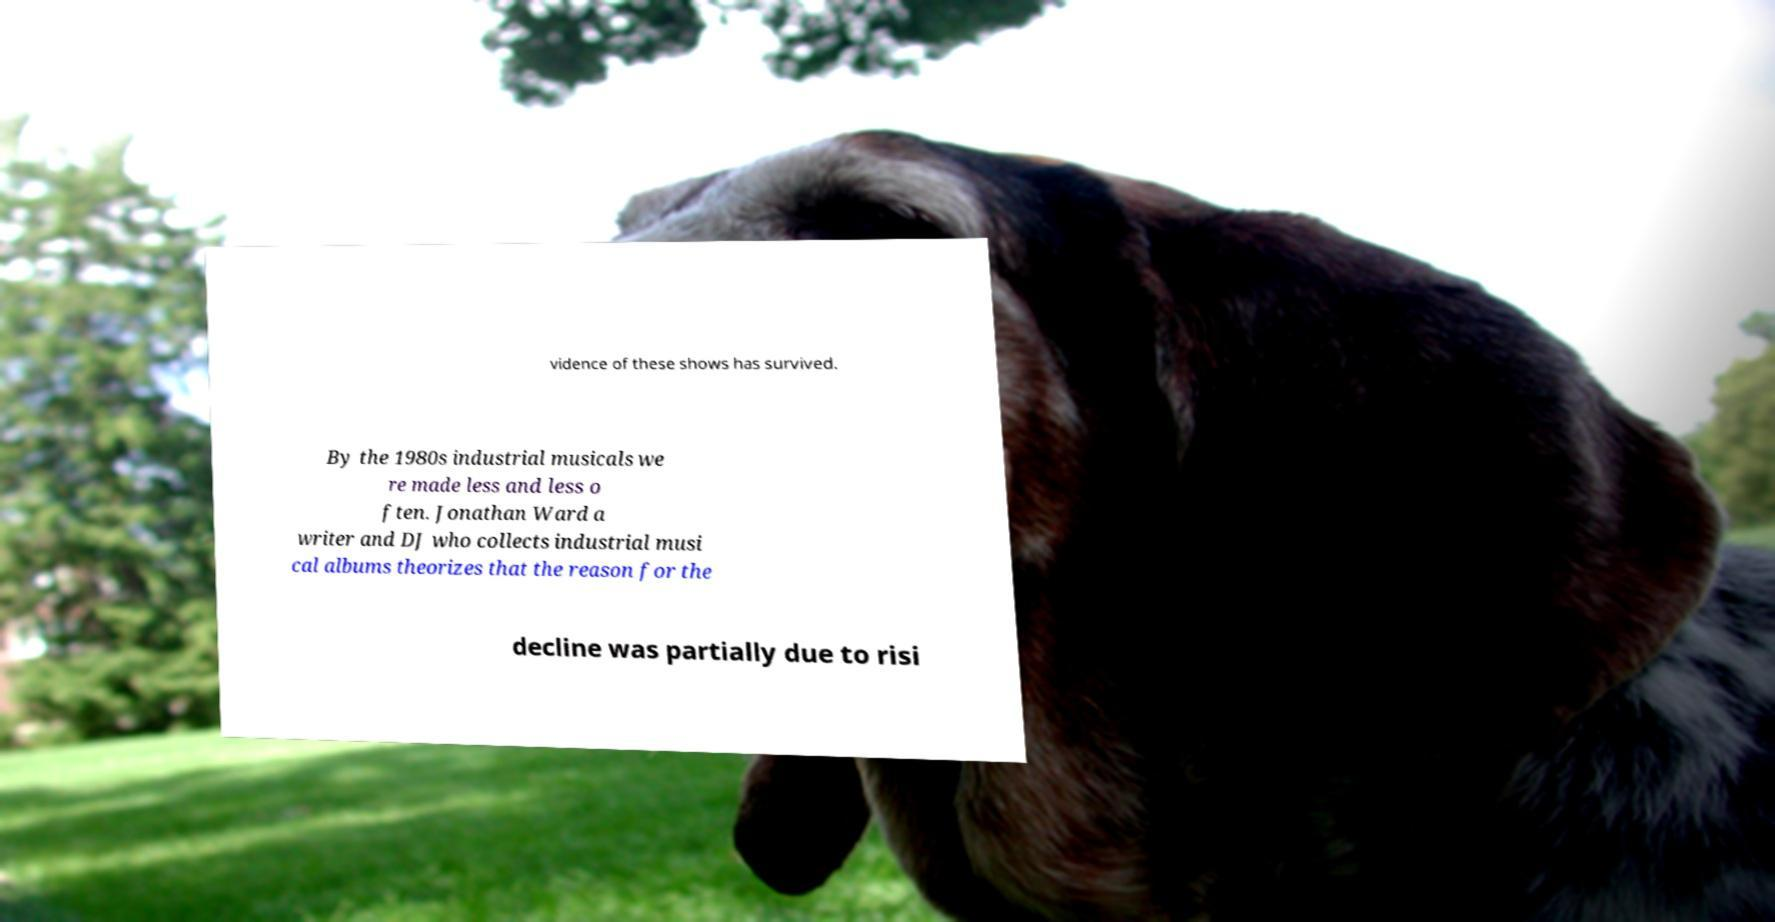Could you assist in decoding the text presented in this image and type it out clearly? vidence of these shows has survived. By the 1980s industrial musicals we re made less and less o ften. Jonathan Ward a writer and DJ who collects industrial musi cal albums theorizes that the reason for the decline was partially due to risi 